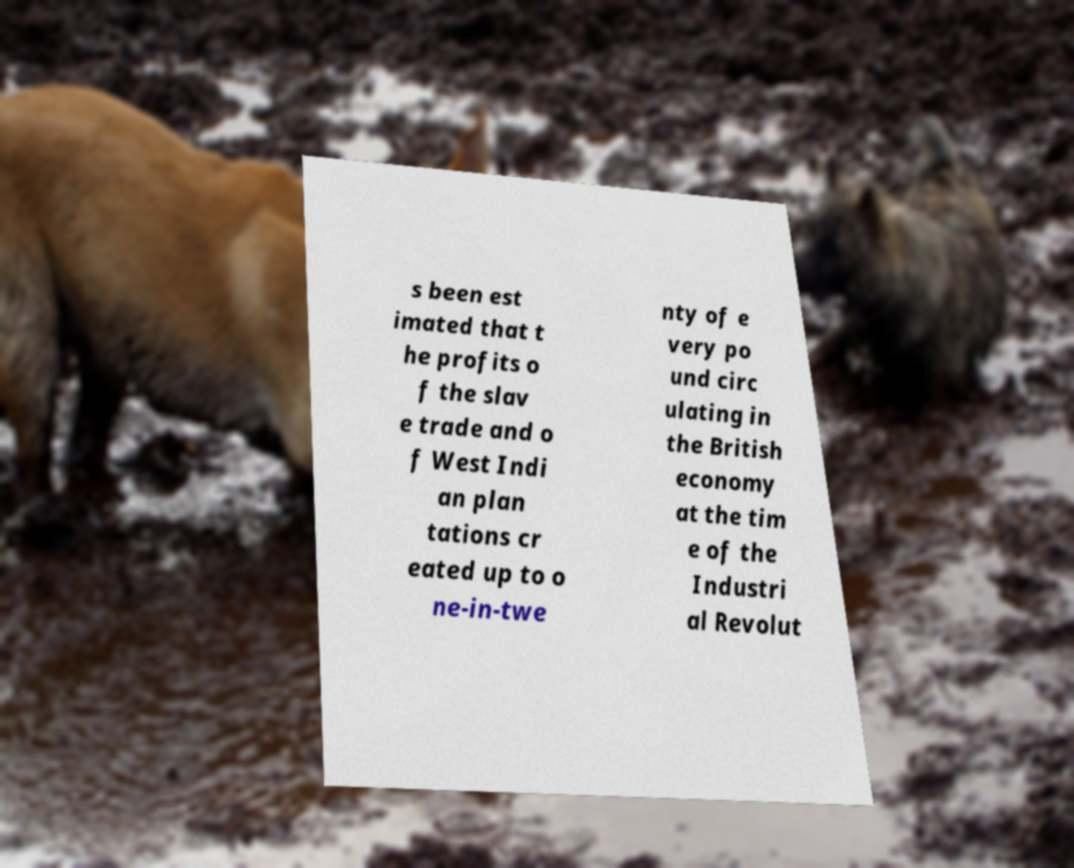I need the written content from this picture converted into text. Can you do that? s been est imated that t he profits o f the slav e trade and o f West Indi an plan tations cr eated up to o ne-in-twe nty of e very po und circ ulating in the British economy at the tim e of the Industri al Revolut 